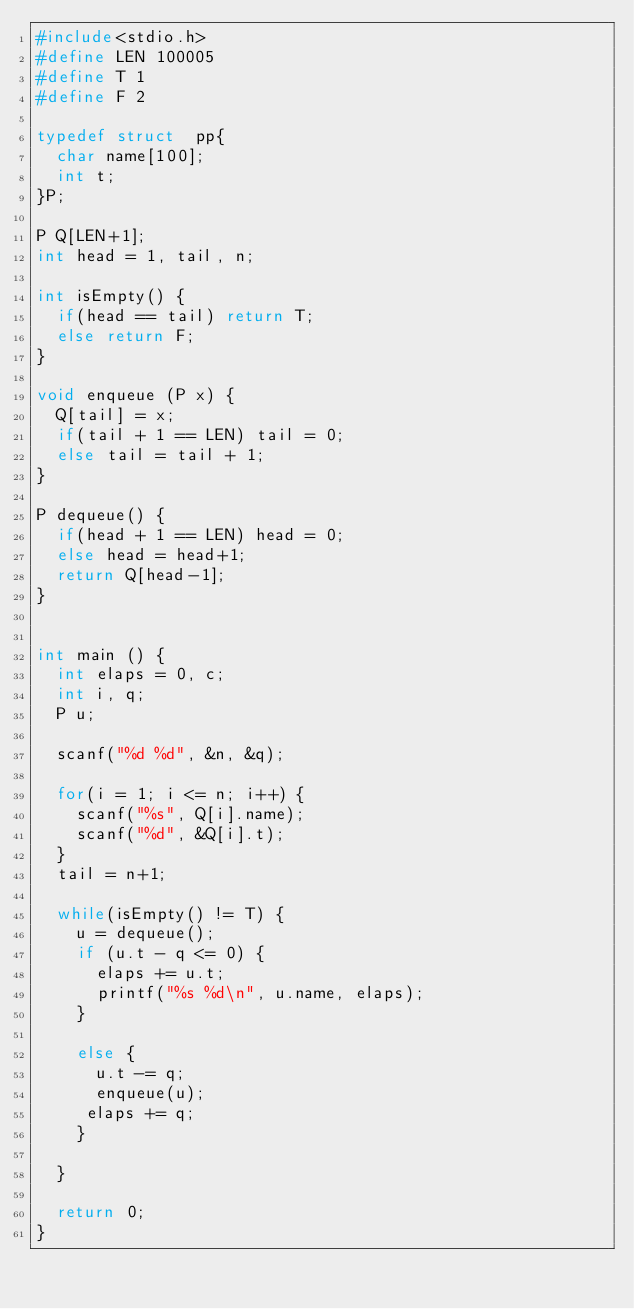Convert code to text. <code><loc_0><loc_0><loc_500><loc_500><_C_>#include<stdio.h>
#define LEN 100005
#define T 1
#define F 2

typedef struct  pp{
  char name[100];
  int t;
}P;

P Q[LEN+1];
int head = 1, tail, n; 

int isEmpty() {
  if(head == tail) return T;
  else return F;
}

void enqueue (P x) {
  Q[tail] = x;
  if(tail + 1 == LEN) tail = 0;
  else tail = tail + 1;
}

P dequeue() {
  if(head + 1 == LEN) head = 0;
  else head = head+1;
  return Q[head-1];
}


int main () {
  int elaps = 0, c;
  int i, q;
  P u;

  scanf("%d %d", &n, &q);

  for(i = 1; i <= n; i++) {
    scanf("%s", Q[i].name);
    scanf("%d", &Q[i].t);
  }
  tail = n+1;

  while(isEmpty() != T) {
    u = dequeue();
    if (u.t - q <= 0) {
      elaps += u.t;
      printf("%s %d\n", u.name, elaps);
    }

    else {
      u.t -= q;
      enqueue(u);
     elaps += q; 
    }
       
  }
 
  return 0;
}</code> 